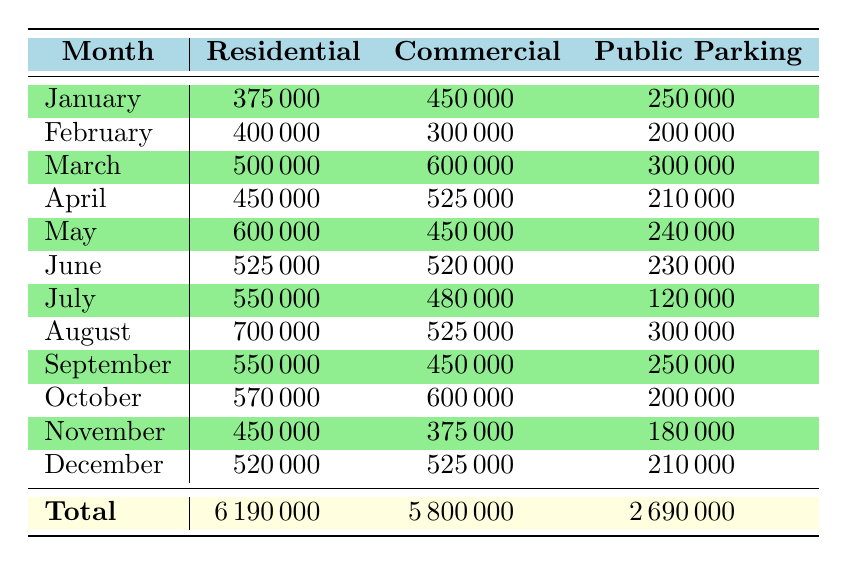What was the total settlement amount for Commercial Properties in March? In March, the table shows that the total settlement amount for Commercial Properties was 600,000.
Answer: 600000 How many claims were filed for Public Parking Lots in August? The table indicates that in August, there were 30 claims filed for Public Parking Lots.
Answer: 30 What was the average settlement amount for Residential Properties in January? The table provides the average settlement amount for Residential Properties in January as 8,333.
Answer: 8333 Which month had the highest total settlement amount for Residential Properties? By comparing the total settlement amounts for Residential Properties across the months, August stands out with a total of 700,000.
Answer: August Was the average settlement amount for Public Parking Lots in December higher than 13,000? In December, the average settlement amount for Public Parking Lots was 14,000, which is indeed higher than 13,000.
Answer: Yes What is the total number of claims for Commercial Properties across all months? Summing the total claims for Commercial Properties from each month: 30 + 25 + 40 + 35 + 30 + 40 + 30 + 35 + 30 + 40 + 25 + 35 = 425.
Answer: 425 Which month had the lowest total claims filed for Residential Properties? Looking at the total claims for Residential Properties across all months, February had the lowest with 50 claims.
Answer: February If we consider the total settlement amounts, what is the difference between Residential and Commercial Properties for the year? Totaling the amounts gives us: Residential 6,190,000 and Commercial 5,800,000; the difference is 6,190,000 - 5,800,000 = 390,000.
Answer: 390000 How does the average settlement amount for Public Parking Lots in June compare to that in July? In June, the average settlement amount for Public Parking Lots was 11,500, while in July it was 12,000; therefore, July’s average is higher.
Answer: July 